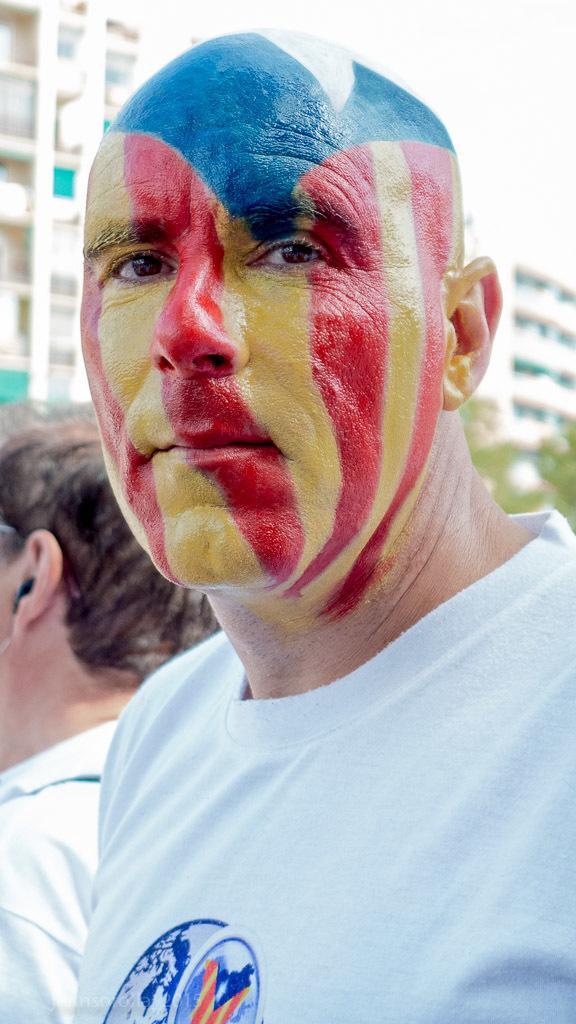Please provide a concise description of this image. In the foreground of the picture there is a person wearing a white t-shirt and having face painted, behind him there is a person. The background is blurred. In the background there are buildings and trees. 